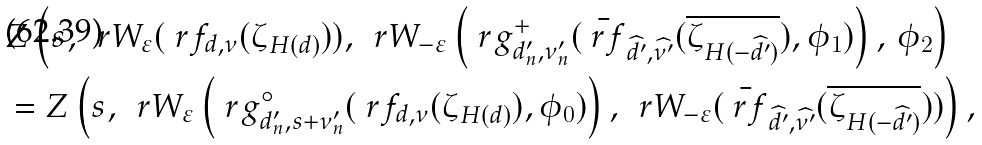<formula> <loc_0><loc_0><loc_500><loc_500>& Z \left ( s , \, \ r W _ { \varepsilon } ( \ r f _ { d , \nu } ( \zeta _ { H ( d ) } ) ) , \, \ r W _ { - \varepsilon } \left ( \ r g ^ { + } _ { d _ { n } ^ { \prime } , \nu _ { n } ^ { \prime } } ( \bar { \ r f } _ { \widehat { d ^ { \prime } } , \widehat { \nu ^ { \prime } } } ( \overline { \zeta _ { H ( - \widehat { d ^ { \prime } } ) } } ) , \phi _ { 1 } ) \right ) , \, \phi _ { 2 } \right ) \\ & = Z \left ( s , \, \ r W _ { \varepsilon } \left ( \ r g ^ { \circ } _ { d _ { n } ^ { \prime } , s + \nu _ { n } ^ { \prime } } ( \ r f _ { d , \nu } ( \zeta _ { H ( d ) } ) , \phi _ { 0 } ) \right ) , \, \ r W _ { - \varepsilon } ( \bar { \ r f } _ { \widehat { d ^ { \prime } } , \widehat { \nu ^ { \prime } } } ( \overline { \zeta _ { H ( - \widehat { d ^ { \prime } } ) } } ) ) \right ) ,</formula> 